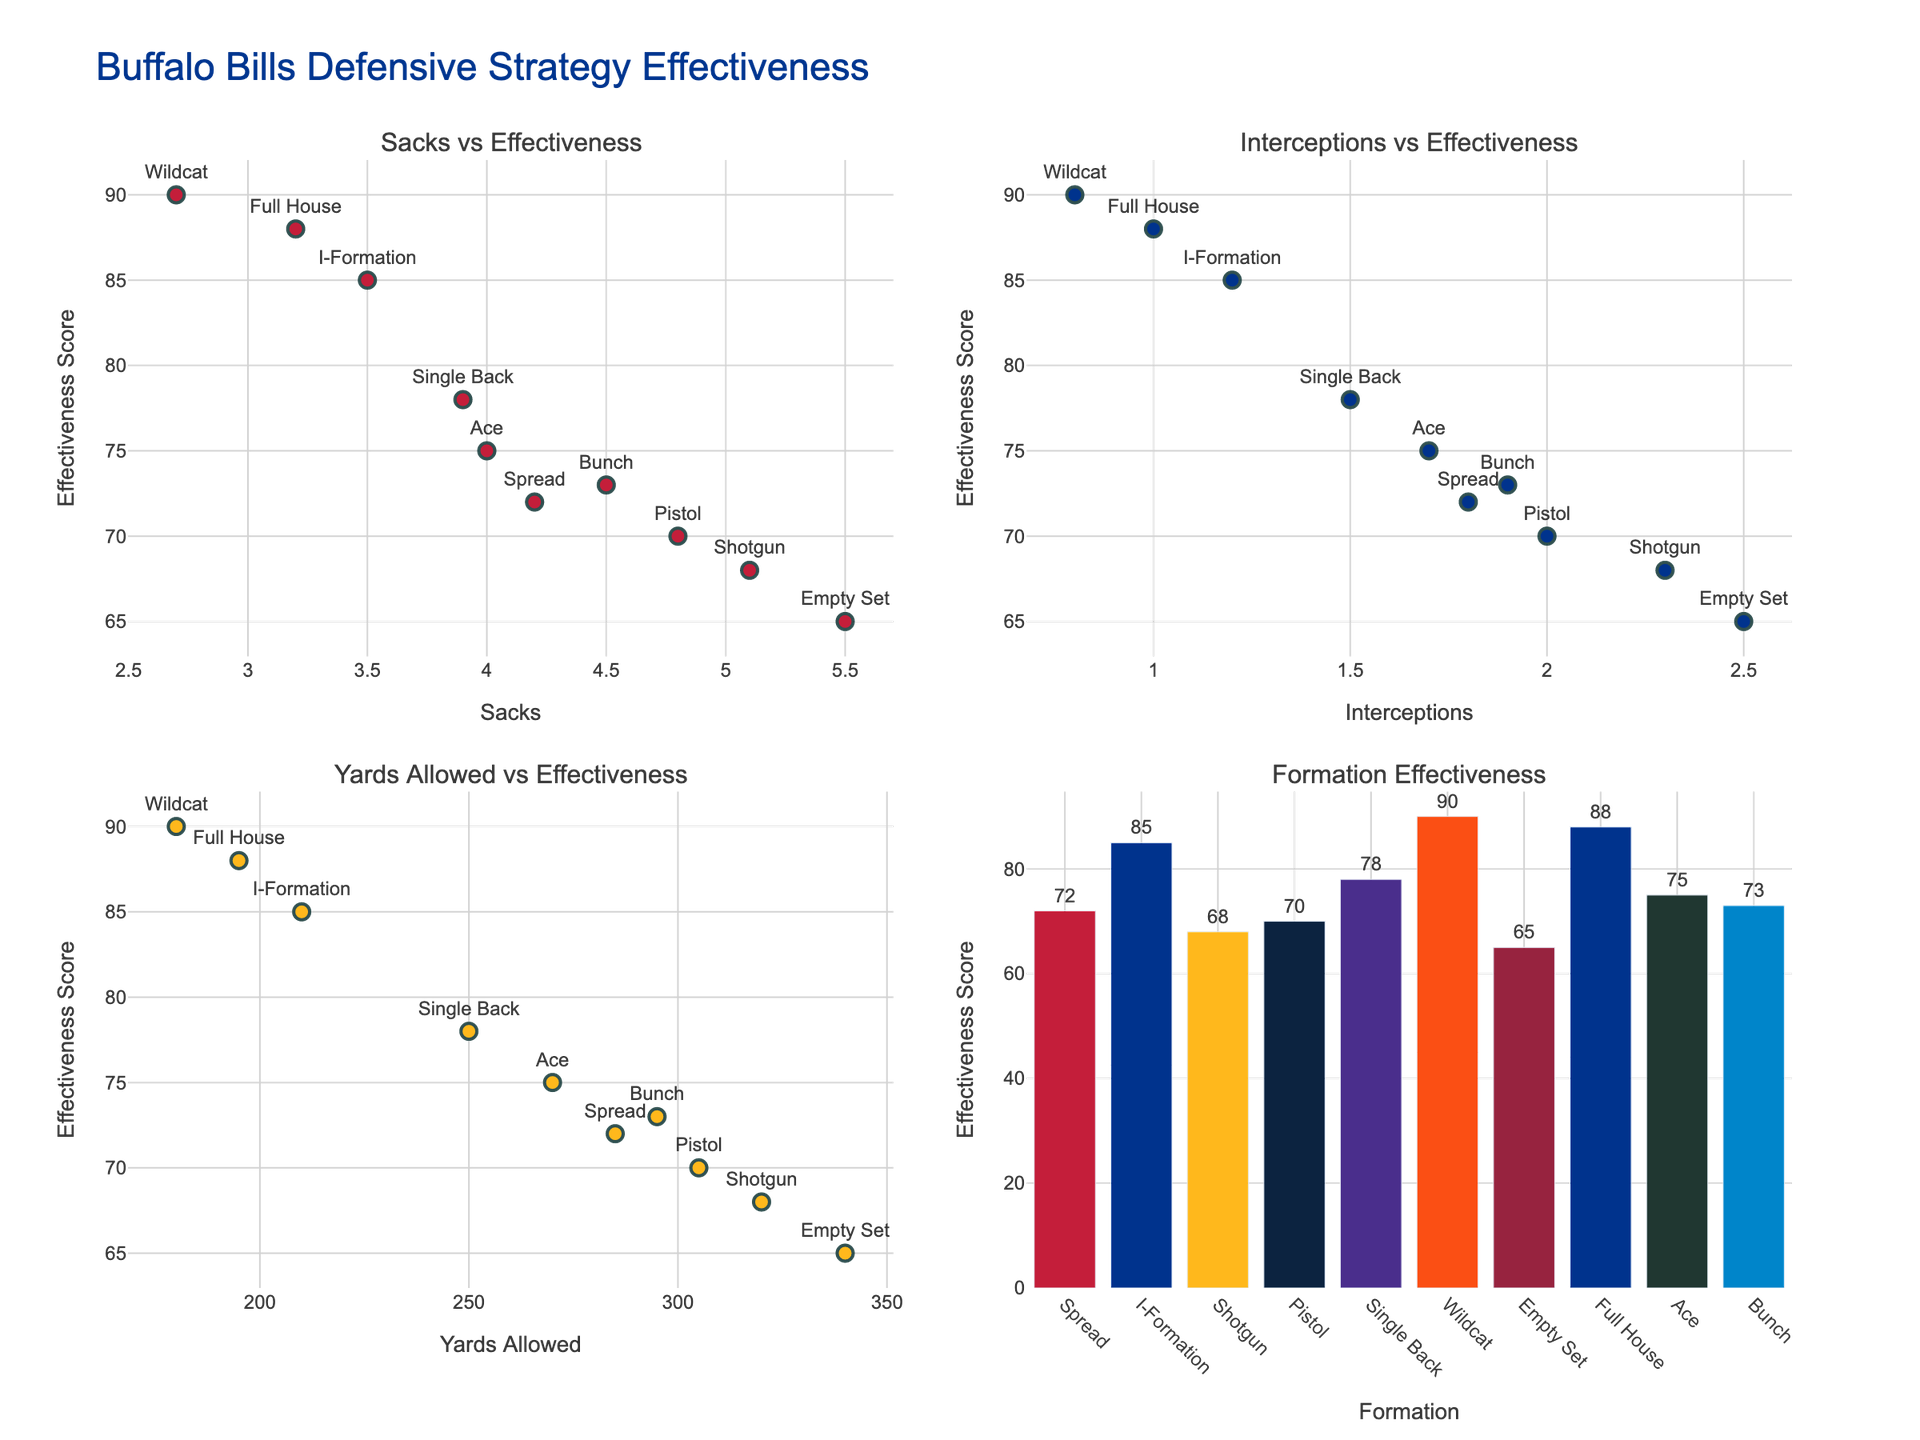Which formation has the highest effectiveness score? The bar chart for Formation Effectiveness displays the scores for each formation. By examining the bars, the formation with the highest bar represents the highest effectiveness score. Wildcat has the highest bar, corresponding to an effectiveness score of 90.
Answer: Wildcat Which formation allows the fewest yards? In the scatter plot for Yards Allowed vs Effectiveness, the formation with the lowest 'Yards Allowed' value on the x-axis can be identified. Wildcat allows the fewest yards, with 180 yards allowed.
Answer: Wildcat What’s the effectiveness score for formations with the highest number of sacks? In the scatter plot for Sacks vs Effectiveness, the highest data point on the x-axis represents the formation with the highest number of sacks. The effectiveness score for this data point can be read off the y-axis. The formation with the highest sacks is Empty Set with 5.5 sacks, and its effectiveness score is 65.
Answer: 65 Which formation has the second highest interceptions? In the scatter plot for Interceptions vs Effectiveness, locate the second highest data point on the x-axis for interceptions. The text label for this point indicates the formation. The second highest interceptions are recorded by the Pistol formation, with 2.0 interceptions.
Answer: Pistol How does the effectiveness score compare between Bunch and Single Back formations? For both formations, locate their bars in the Formation Effectiveness bar chart or their points in multiple scatter plots related to Effectiveness Score. Bunch has an effectiveness score of 73, while Single Back has 78. Single Back has a higher effectiveness score than Bunch.
Answer: Single Back has a higher effectiveness score By how much do effectiveness scores of formations change when comparing the highest and lowest sack counts? Identify the effectiveness scores for formations with the highest (Empty Set with 5.5 sacks) and lowest (Wildcat with 2.7 sacks) sacks in the scatter plot for Sacks vs Effectiveness. Calculate the difference. The highest is 65 and the lowest is 90, so the change is 90 - 65 = 25.
Answer: 25 What is the average effectiveness score across all formations? Extract all effectiveness scores from the visualizations and calculate their average. The scores (72, 85, 68, 70, 78, 90, 65, 88, 75, 73) sum to 764. The average is 764 / 10 = 76.4.
Answer: 76.4 Which formation has similar effectiveness scores despite different yards allowed? Compare points in the scatter plots for Yards Allowed vs Effectiveness. Formations with similar y-values (effectiveness scores) but different x-values (yards allowed) meet this criterion. Spread and Bunch formations both have effectiveness scores close to 72 and 73, but Spread allows 285 yards while Bunch allows 295 yards.
Answer: Spread and Bunch 